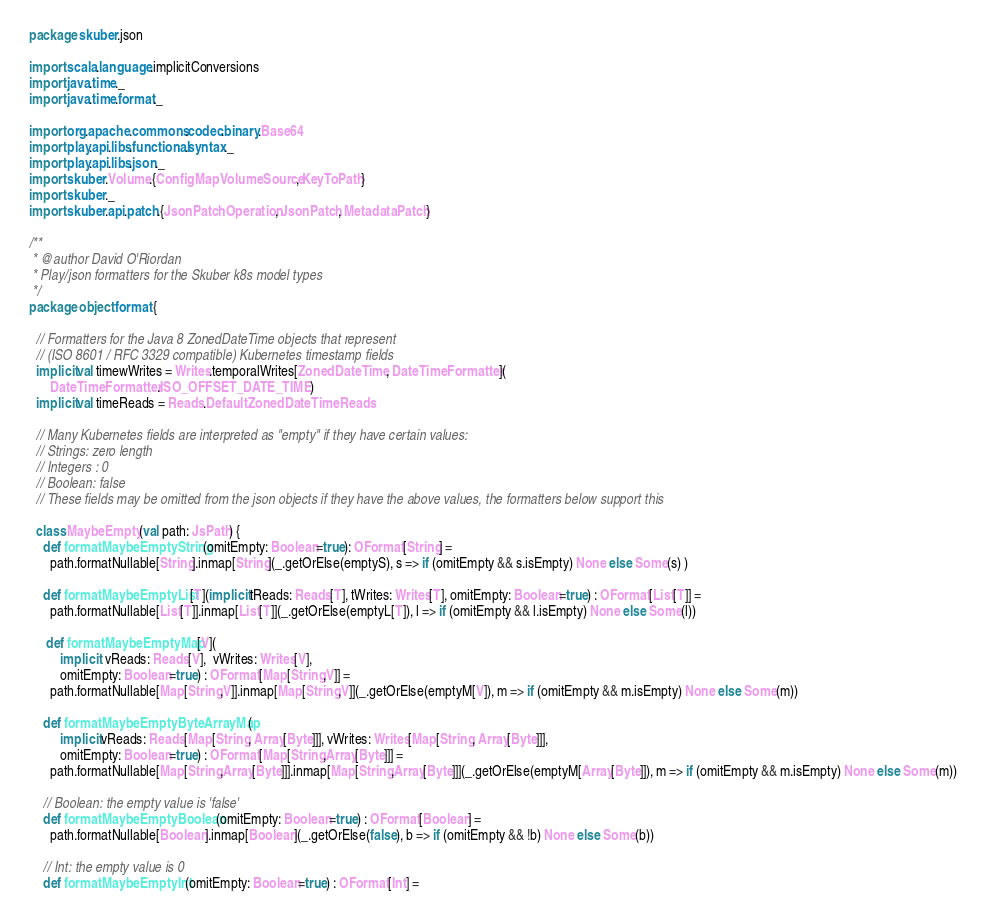Convert code to text. <code><loc_0><loc_0><loc_500><loc_500><_Scala_>package skuber.json

import scala.language.implicitConversions
import java.time._
import java.time.format._

import org.apache.commons.codec.binary.Base64
import play.api.libs.functional.syntax._
import play.api.libs.json._
import skuber.Volume.{ConfigMapVolumeSource, KeyToPath}
import skuber._
import skuber.api.patch.{JsonPatchOperation, JsonPatch, MetadataPatch}

/**
 * @author David O'Riordan
 * Play/json formatters for the Skuber k8s model types
 */
package object format {
  
  // Formatters for the Java 8 ZonedDateTime objects that represent
  // (ISO 8601 / RFC 3329 compatible) Kubernetes timestamp fields 
  implicit val timewWrites = Writes.temporalWrites[ZonedDateTime, DateTimeFormatter](
      DateTimeFormatter.ISO_OFFSET_DATE_TIME)
  implicit val timeReads = Reads.DefaultZonedDateTimeReads    
      
  // Many Kubernetes fields are interpreted as "empty" if they have certain values:
  // Strings: zero length
  // Integers : 0 
  // Boolean: false
  // These fields may be omitted from the json objects if they have the above values, the formatters below support this
  
  class MaybeEmpty(val path: JsPath) {
    def formatMaybeEmptyString(omitEmpty: Boolean=true): OFormat[String] =
      path.formatNullable[String].inmap[String](_.getOrElse(emptyS), s => if (omitEmpty && s.isEmpty) None else Some(s) )
      
    def formatMaybeEmptyList[T](implicit tReads: Reads[T], tWrites: Writes[T], omitEmpty: Boolean=true) : OFormat[List[T]] =
      path.formatNullable[List[T]].inmap[List[T]](_.getOrElse(emptyL[T]), l => if (omitEmpty && l.isEmpty) None else Some(l))
      
     def formatMaybeEmptyMap[V](
         implicit  vReads: Reads[V],  vWrites: Writes[V],
         omitEmpty: Boolean=true) : OFormat[Map[String,V]] =
      path.formatNullable[Map[String,V]].inmap[Map[String,V]](_.getOrElse(emptyM[V]), m => if (omitEmpty && m.isEmpty) None else Some(m))

    def formatMaybeEmptyByteArrayMap(
         implicit vReads: Reads[Map[String, Array[Byte]]], vWrites: Writes[Map[String, Array[Byte]]],
         omitEmpty: Boolean=true) : OFormat[Map[String,Array[Byte]]] =
      path.formatNullable[Map[String,Array[Byte]]].inmap[Map[String,Array[Byte]]](_.getOrElse(emptyM[Array[Byte]]), m => if (omitEmpty && m.isEmpty) None else Some(m))

    // Boolean: the empty value is 'false'  
    def formatMaybeEmptyBoolean(omitEmpty: Boolean=true) : OFormat[Boolean] =
      path.formatNullable[Boolean].inmap[Boolean](_.getOrElse(false), b => if (omitEmpty && !b) None else Some(b))
      
    // Int: the empty value is 0
    def formatMaybeEmptyInt(omitEmpty: Boolean=true) : OFormat[Int] =</code> 